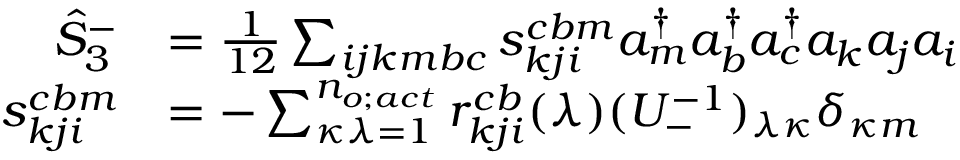Convert formula to latex. <formula><loc_0><loc_0><loc_500><loc_500>\begin{array} { r l } { \hat { S } _ { 3 } ^ { - } } & { = \frac { 1 } { 1 2 } \sum _ { i j k m b c } s _ { k j i } ^ { c b m } a _ { m } ^ { \dagger } a _ { b } ^ { \dagger } a _ { c } ^ { \dagger } a _ { k } a _ { j } a _ { i } } \\ { s _ { k j i } ^ { c b m } } & { = - \sum _ { \kappa \lambda = 1 } ^ { n _ { o ; a c t } } r _ { k j i } ^ { c b } ( \lambda ) ( U _ { - } ^ { - 1 } ) _ { \lambda \kappa } \delta _ { \kappa m } } \end{array}</formula> 